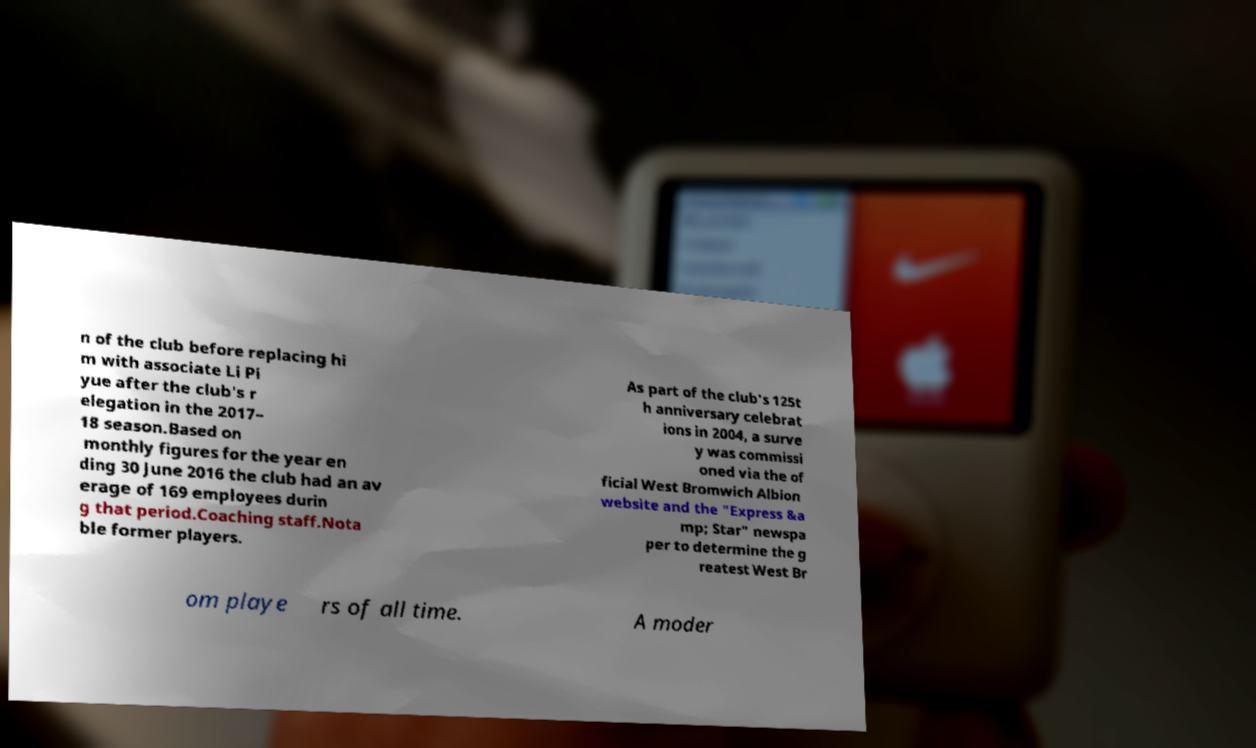For documentation purposes, I need the text within this image transcribed. Could you provide that? n of the club before replacing hi m with associate Li Pi yue after the club's r elegation in the 2017– 18 season.Based on monthly figures for the year en ding 30 June 2016 the club had an av erage of 169 employees durin g that period.Coaching staff.Nota ble former players. As part of the club's 125t h anniversary celebrat ions in 2004, a surve y was commissi oned via the of ficial West Bromwich Albion website and the "Express &a mp; Star" newspa per to determine the g reatest West Br om playe rs of all time. A moder 